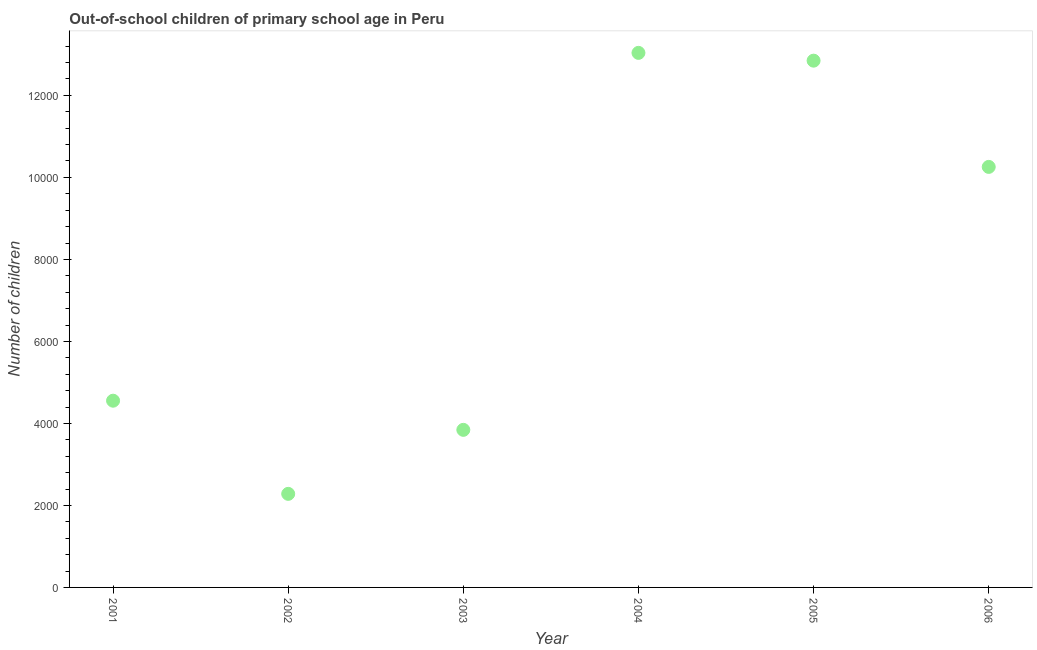What is the number of out-of-school children in 2003?
Offer a very short reply. 3843. Across all years, what is the maximum number of out-of-school children?
Provide a short and direct response. 1.30e+04. Across all years, what is the minimum number of out-of-school children?
Offer a very short reply. 2282. In which year was the number of out-of-school children minimum?
Your response must be concise. 2002. What is the sum of the number of out-of-school children?
Your response must be concise. 4.68e+04. What is the difference between the number of out-of-school children in 2001 and 2005?
Your answer should be compact. -8293. What is the average number of out-of-school children per year?
Your answer should be very brief. 7803.17. What is the median number of out-of-school children?
Keep it short and to the point. 7405. What is the ratio of the number of out-of-school children in 2001 to that in 2006?
Your response must be concise. 0.44. Is the number of out-of-school children in 2003 less than that in 2005?
Ensure brevity in your answer.  Yes. What is the difference between the highest and the second highest number of out-of-school children?
Keep it short and to the point. 190. What is the difference between the highest and the lowest number of out-of-school children?
Your answer should be very brief. 1.08e+04. In how many years, is the number of out-of-school children greater than the average number of out-of-school children taken over all years?
Offer a very short reply. 3. What is the difference between two consecutive major ticks on the Y-axis?
Ensure brevity in your answer.  2000. Are the values on the major ticks of Y-axis written in scientific E-notation?
Provide a short and direct response. No. What is the title of the graph?
Provide a short and direct response. Out-of-school children of primary school age in Peru. What is the label or title of the Y-axis?
Make the answer very short. Number of children. What is the Number of children in 2001?
Keep it short and to the point. 4554. What is the Number of children in 2002?
Your answer should be compact. 2282. What is the Number of children in 2003?
Provide a succinct answer. 3843. What is the Number of children in 2004?
Your response must be concise. 1.30e+04. What is the Number of children in 2005?
Ensure brevity in your answer.  1.28e+04. What is the Number of children in 2006?
Provide a succinct answer. 1.03e+04. What is the difference between the Number of children in 2001 and 2002?
Give a very brief answer. 2272. What is the difference between the Number of children in 2001 and 2003?
Keep it short and to the point. 711. What is the difference between the Number of children in 2001 and 2004?
Make the answer very short. -8483. What is the difference between the Number of children in 2001 and 2005?
Your response must be concise. -8293. What is the difference between the Number of children in 2001 and 2006?
Keep it short and to the point. -5702. What is the difference between the Number of children in 2002 and 2003?
Keep it short and to the point. -1561. What is the difference between the Number of children in 2002 and 2004?
Keep it short and to the point. -1.08e+04. What is the difference between the Number of children in 2002 and 2005?
Ensure brevity in your answer.  -1.06e+04. What is the difference between the Number of children in 2002 and 2006?
Offer a very short reply. -7974. What is the difference between the Number of children in 2003 and 2004?
Ensure brevity in your answer.  -9194. What is the difference between the Number of children in 2003 and 2005?
Make the answer very short. -9004. What is the difference between the Number of children in 2003 and 2006?
Your response must be concise. -6413. What is the difference between the Number of children in 2004 and 2005?
Offer a very short reply. 190. What is the difference between the Number of children in 2004 and 2006?
Keep it short and to the point. 2781. What is the difference between the Number of children in 2005 and 2006?
Provide a short and direct response. 2591. What is the ratio of the Number of children in 2001 to that in 2002?
Make the answer very short. 2. What is the ratio of the Number of children in 2001 to that in 2003?
Your answer should be very brief. 1.19. What is the ratio of the Number of children in 2001 to that in 2004?
Offer a terse response. 0.35. What is the ratio of the Number of children in 2001 to that in 2005?
Make the answer very short. 0.35. What is the ratio of the Number of children in 2001 to that in 2006?
Give a very brief answer. 0.44. What is the ratio of the Number of children in 2002 to that in 2003?
Make the answer very short. 0.59. What is the ratio of the Number of children in 2002 to that in 2004?
Provide a succinct answer. 0.17. What is the ratio of the Number of children in 2002 to that in 2005?
Make the answer very short. 0.18. What is the ratio of the Number of children in 2002 to that in 2006?
Give a very brief answer. 0.22. What is the ratio of the Number of children in 2003 to that in 2004?
Offer a very short reply. 0.29. What is the ratio of the Number of children in 2003 to that in 2005?
Your response must be concise. 0.3. What is the ratio of the Number of children in 2004 to that in 2005?
Offer a terse response. 1.01. What is the ratio of the Number of children in 2004 to that in 2006?
Provide a succinct answer. 1.27. What is the ratio of the Number of children in 2005 to that in 2006?
Keep it short and to the point. 1.25. 